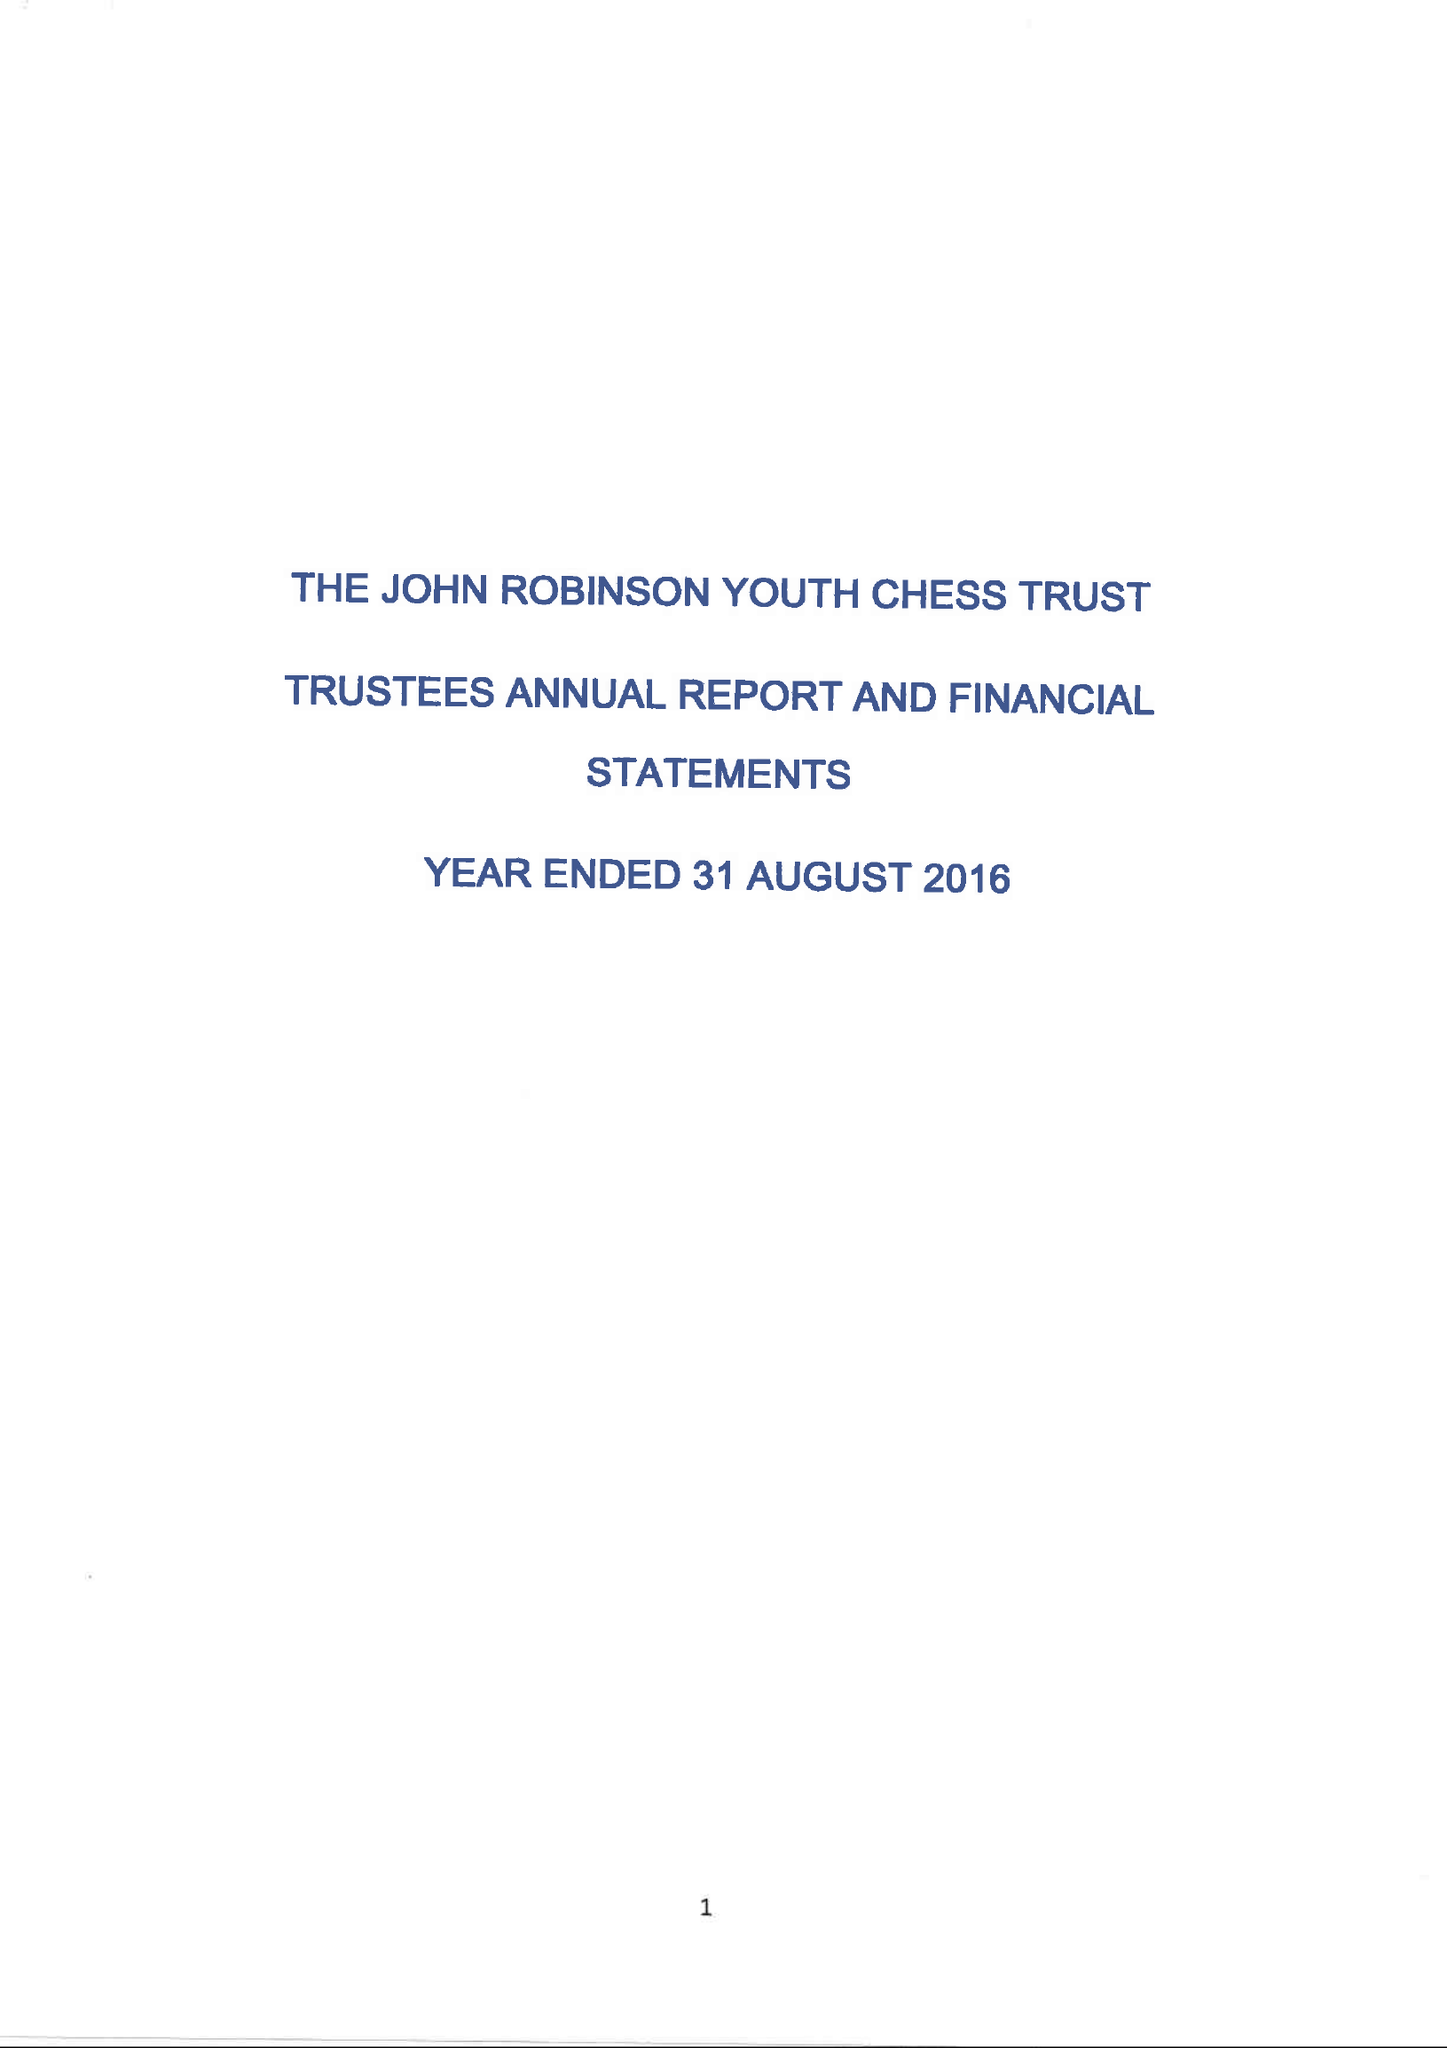What is the value for the charity_number?
Answer the question using a single word or phrase. 1116981 